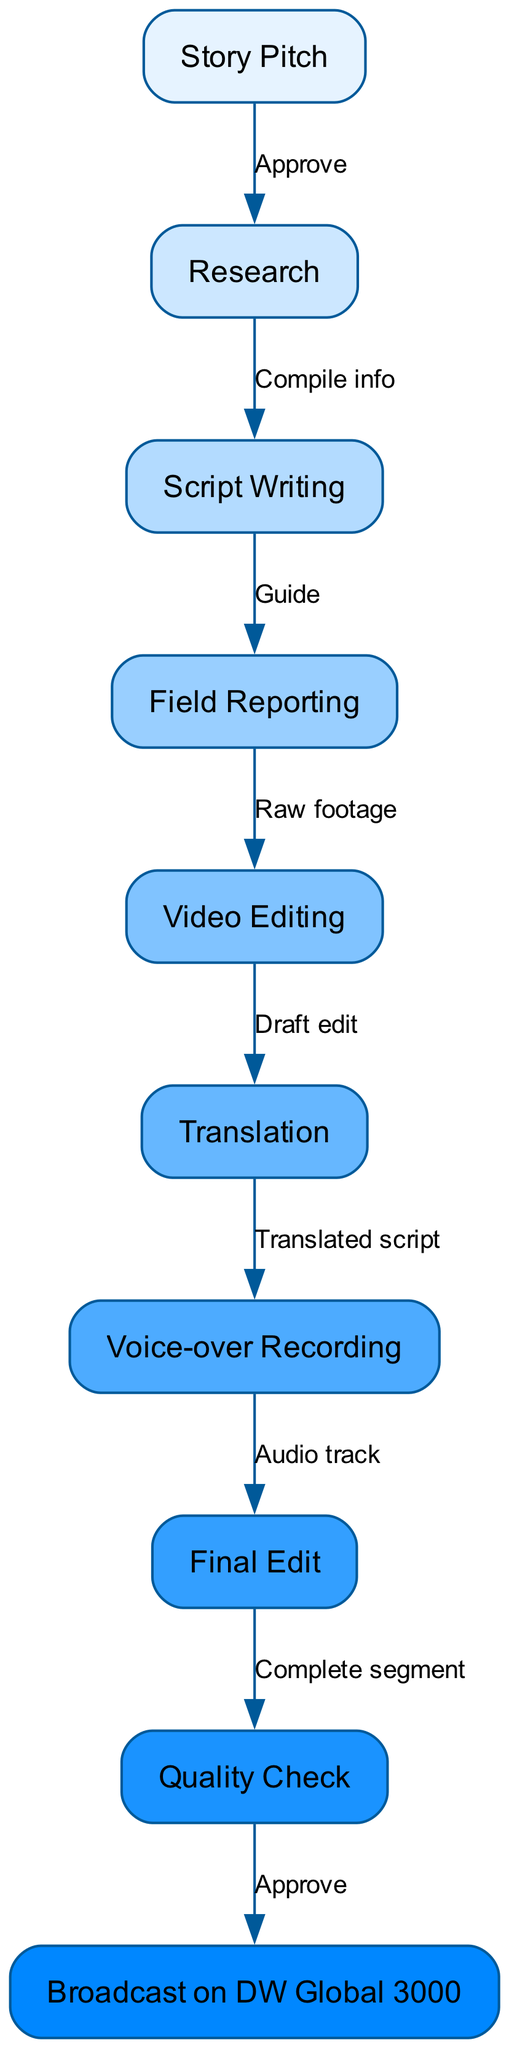What is the first step in the production process? The first step listed in the diagram is "Story Pitch", which is the initial action in creating the news segment.
Answer: Story Pitch How many nodes are in the diagram? The diagram contains ten nodes that represent different stages in the production process.
Answer: Ten What is the label connecting “Research” and “Script Writing”? The label that connects these two nodes is "Compile info", indicating how the research phase feeds into the script writing phase.
Answer: Compile info Which node comes after "Video Editing"? Following "Video Editing", the next step in the production process is "Translation", showing the sequence of editing leading into translation efforts.
Answer: Translation What is the endpoint of the production process? The endpoint of the production process as depicted in the diagram is "Broadcast on DW Global 3000", showcasing where the completed segment finally airs.
Answer: Broadcast on DW Global 3000 How many edges are present in the diagram? There are nine edges in the diagram, which denote the relationships and flow of information between the various production stages.
Answer: Nine What is the connection label between "Final Edit" and "Quality Check"? The connection label between these two nodes is "Complete segment", indicating that the final edit leads into a quality check.
Answer: Complete segment What step immediately follows “Field Reporting”? The step that immediately follows “Field Reporting” is "Video Editing", showing the progression from reporting to editing the footage.
Answer: Video Editing Which node contains the action of recording a voice-over? The "Voice-over Recording" node contains the action of recording a voice-over, which is part of the production process before the final edit.
Answer: Voice-over Recording 